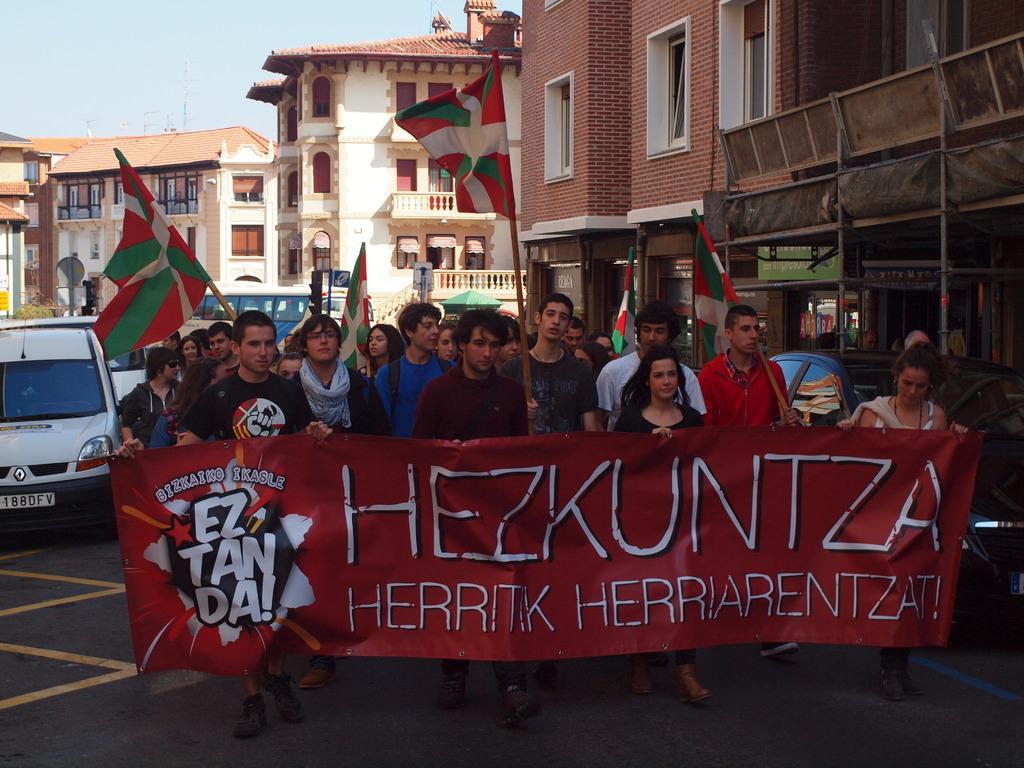In one or two sentences, can you explain what this image depicts? In this picture we can see some persons standing on the road. This is a vehicle on the road. On the background we can see some buildings. This is the sky and these are the flags. 